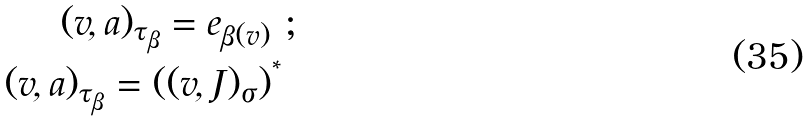<formula> <loc_0><loc_0><loc_500><loc_500>( v , a ) _ { \tau _ { \beta } } = e _ { \beta ( v ) } \ ; \\ ( v , a ) _ { \tau _ { \beta } } = ( ( v , J ) _ { \sigma } ) ^ { ^ { * } } \</formula> 